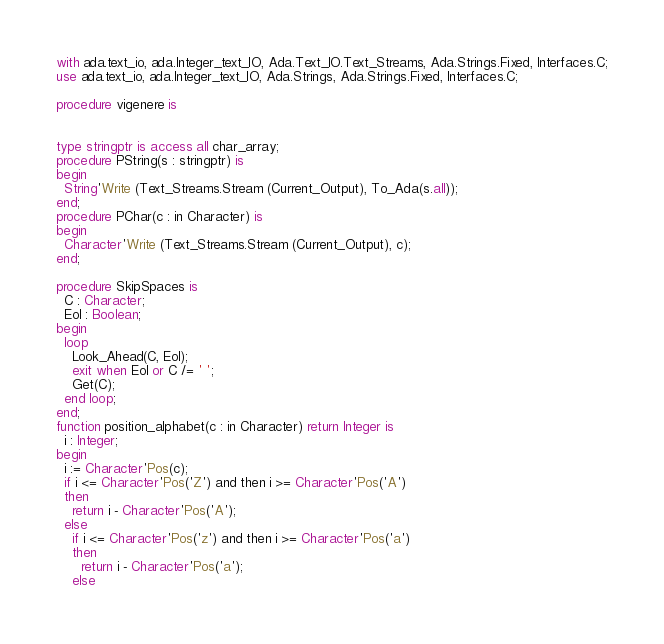Convert code to text. <code><loc_0><loc_0><loc_500><loc_500><_Ada_>
with ada.text_io, ada.Integer_text_IO, Ada.Text_IO.Text_Streams, Ada.Strings.Fixed, Interfaces.C;
use ada.text_io, ada.Integer_text_IO, Ada.Strings, Ada.Strings.Fixed, Interfaces.C;

procedure vigenere is


type stringptr is access all char_array;
procedure PString(s : stringptr) is
begin
  String'Write (Text_Streams.Stream (Current_Output), To_Ada(s.all));
end;
procedure PChar(c : in Character) is
begin
  Character'Write (Text_Streams.Stream (Current_Output), c);
end;

procedure SkipSpaces is
  C : Character;
  Eol : Boolean;
begin
  loop
    Look_Ahead(C, Eol);
    exit when Eol or C /= ' ';
    Get(C);
  end loop;
end;
function position_alphabet(c : in Character) return Integer is
  i : Integer;
begin
  i := Character'Pos(c);
  if i <= Character'Pos('Z') and then i >= Character'Pos('A')
  then
    return i - Character'Pos('A');
  else
    if i <= Character'Pos('z') and then i >= Character'Pos('a')
    then
      return i - Character'Pos('a');
    else</code> 